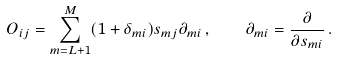<formula> <loc_0><loc_0><loc_500><loc_500>O _ { i j } = \sum _ { m = L + 1 } ^ { M } ( 1 + \delta _ { m i } ) s _ { m j } \partial _ { m i } \, , \quad \partial _ { m i } = \frac { \partial } { \partial s _ { m i } } \, .</formula> 